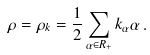Convert formula to latex. <formula><loc_0><loc_0><loc_500><loc_500>\rho = \rho _ { k } = \frac { 1 } { 2 } \sum _ { \alpha \in R _ { + } } k _ { \alpha } \alpha \, .</formula> 